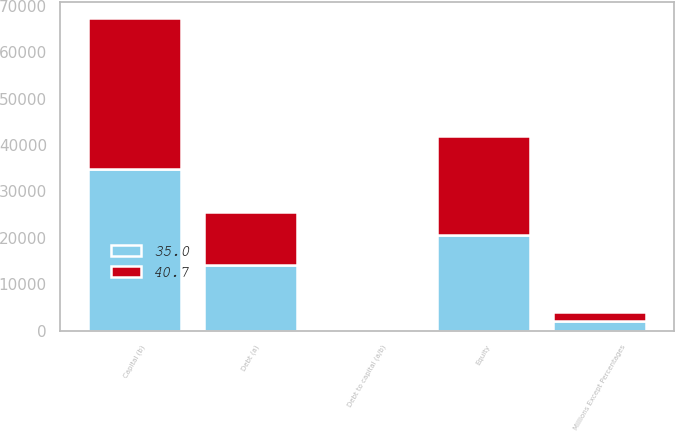<chart> <loc_0><loc_0><loc_500><loc_500><stacked_bar_chart><ecel><fcel>Millions Except Percentages<fcel>Debt (a)<fcel>Equity<fcel>Capital (b)<fcel>Debt to capital (a/b)<nl><fcel>35<fcel>2015<fcel>14201<fcel>20702<fcel>34903<fcel>40.7<nl><fcel>40.7<fcel>2014<fcel>11413<fcel>21189<fcel>32602<fcel>35<nl></chart> 